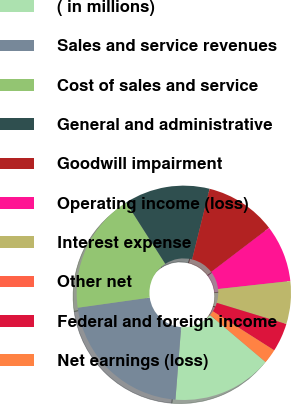Convert chart to OTSL. <chart><loc_0><loc_0><loc_500><loc_500><pie_chart><fcel>( in millions)<fcel>Sales and service revenues<fcel>Cost of sales and service<fcel>General and administrative<fcel>Goodwill impairment<fcel>Operating income (loss)<fcel>Interest expense<fcel>Other net<fcel>Federal and foreign income<fcel>Net earnings (loss)<nl><fcel>15.07%<fcel>21.53%<fcel>18.18%<fcel>12.92%<fcel>10.77%<fcel>8.61%<fcel>6.46%<fcel>0.0%<fcel>4.31%<fcel>2.16%<nl></chart> 